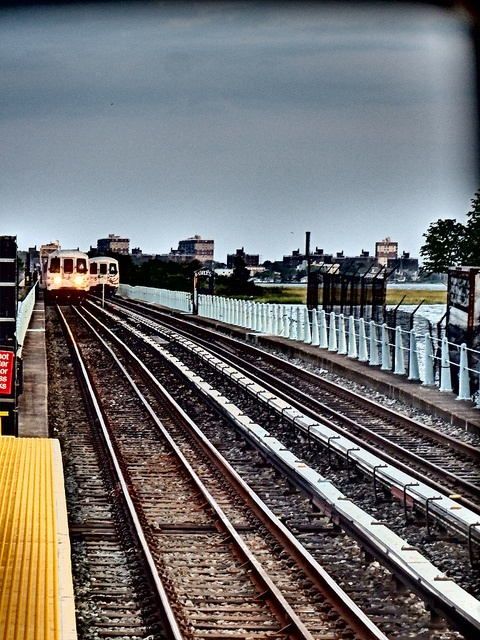Describe the objects in this image and their specific colors. I can see train in black, tan, beige, and maroon tones and train in black, beige, and tan tones in this image. 